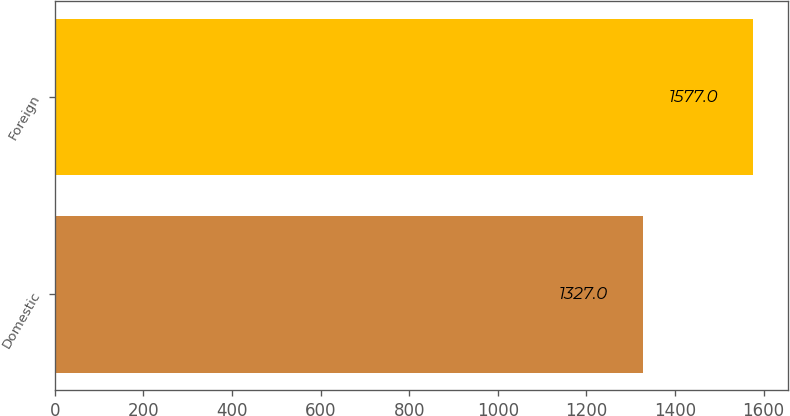<chart> <loc_0><loc_0><loc_500><loc_500><bar_chart><fcel>Domestic<fcel>Foreign<nl><fcel>1327<fcel>1577<nl></chart> 